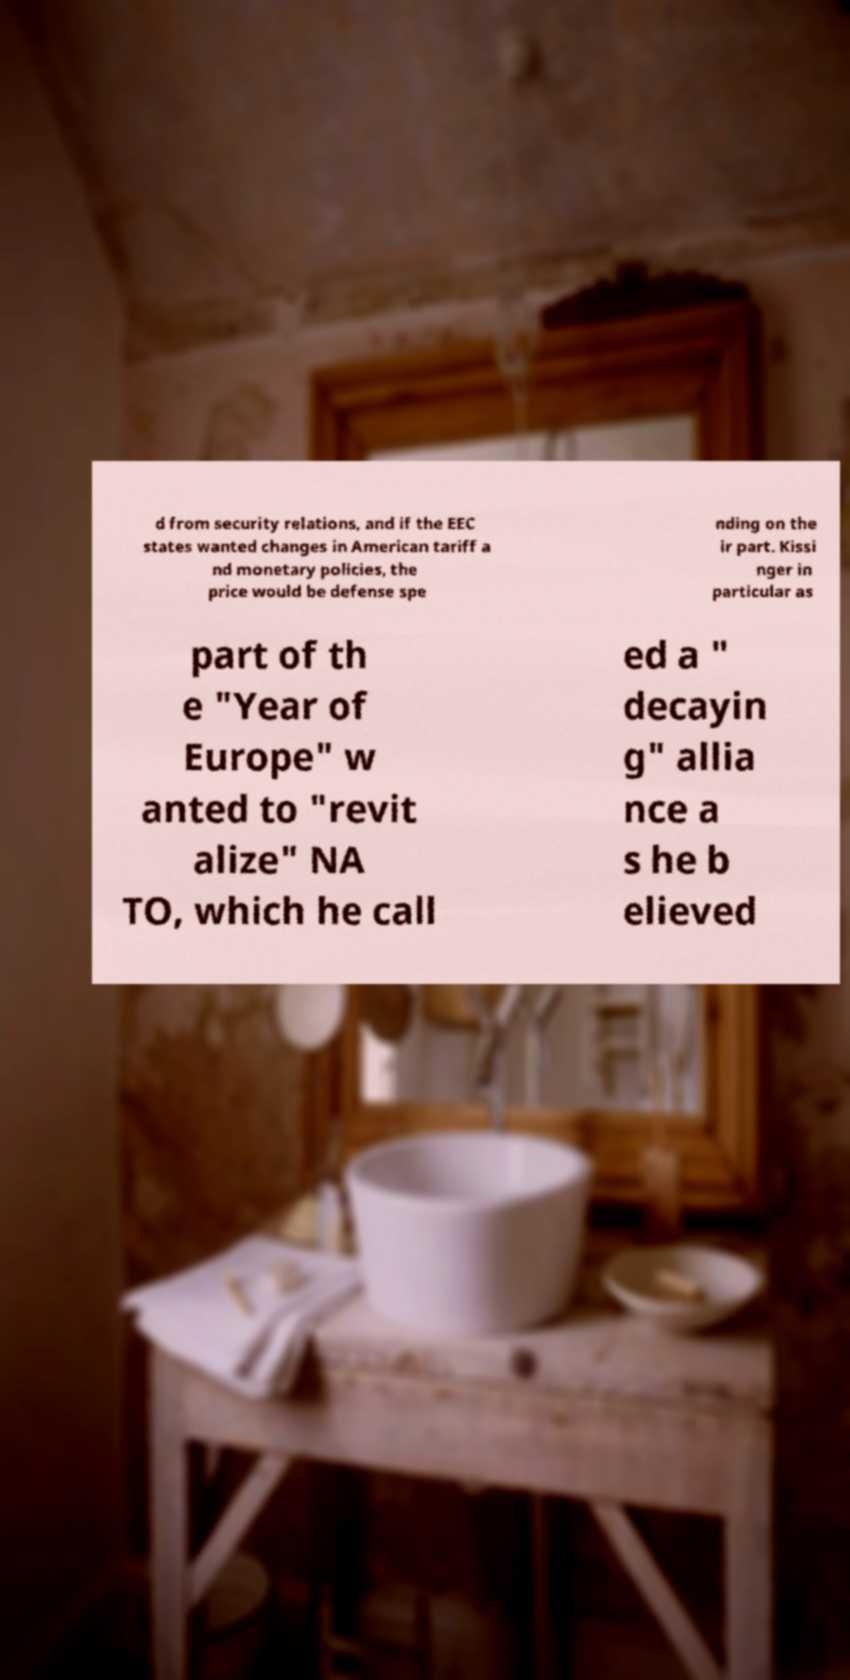I need the written content from this picture converted into text. Can you do that? d from security relations, and if the EEC states wanted changes in American tariff a nd monetary policies, the price would be defense spe nding on the ir part. Kissi nger in particular as part of th e "Year of Europe" w anted to "revit alize" NA TO, which he call ed a " decayin g" allia nce a s he b elieved 